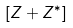<formula> <loc_0><loc_0><loc_500><loc_500>[ Z + Z ^ { * } ]</formula> 